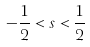Convert formula to latex. <formula><loc_0><loc_0><loc_500><loc_500>- \frac { 1 } { 2 } < s < \frac { 1 } { 2 }</formula> 